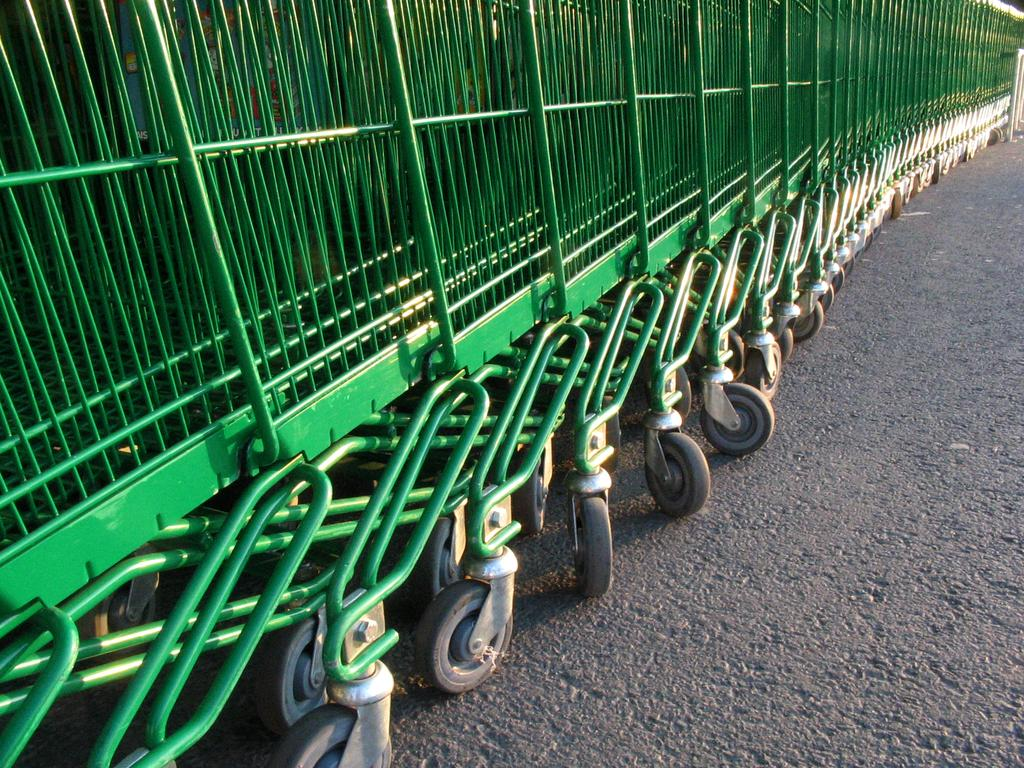What type of objects can be seen in the image? There are trolleys in the image. How are the trolleys arranged in the image? The trolleys are kept in a row. What color are the trolleys in the image? The trolleys are green in color. Where can the store's umbrella be found in the image? There is no store or umbrella present in the image; it only features green trolleys arranged in a row. 